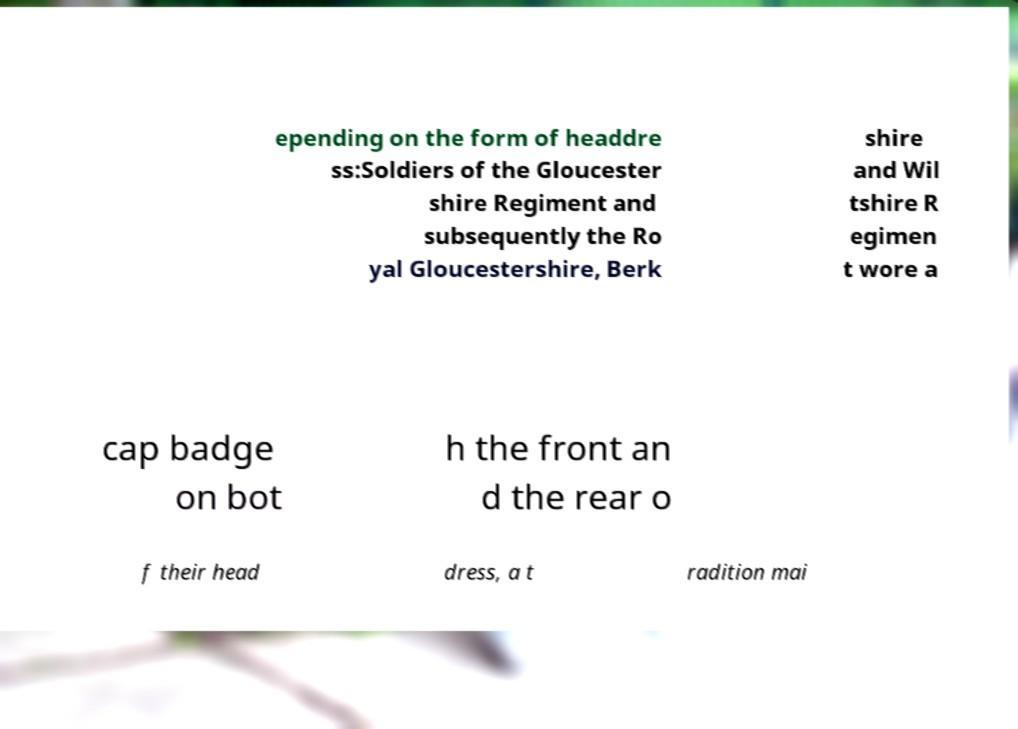For documentation purposes, I need the text within this image transcribed. Could you provide that? epending on the form of headdre ss:Soldiers of the Gloucester shire Regiment and subsequently the Ro yal Gloucestershire, Berk shire and Wil tshire R egimen t wore a cap badge on bot h the front an d the rear o f their head dress, a t radition mai 